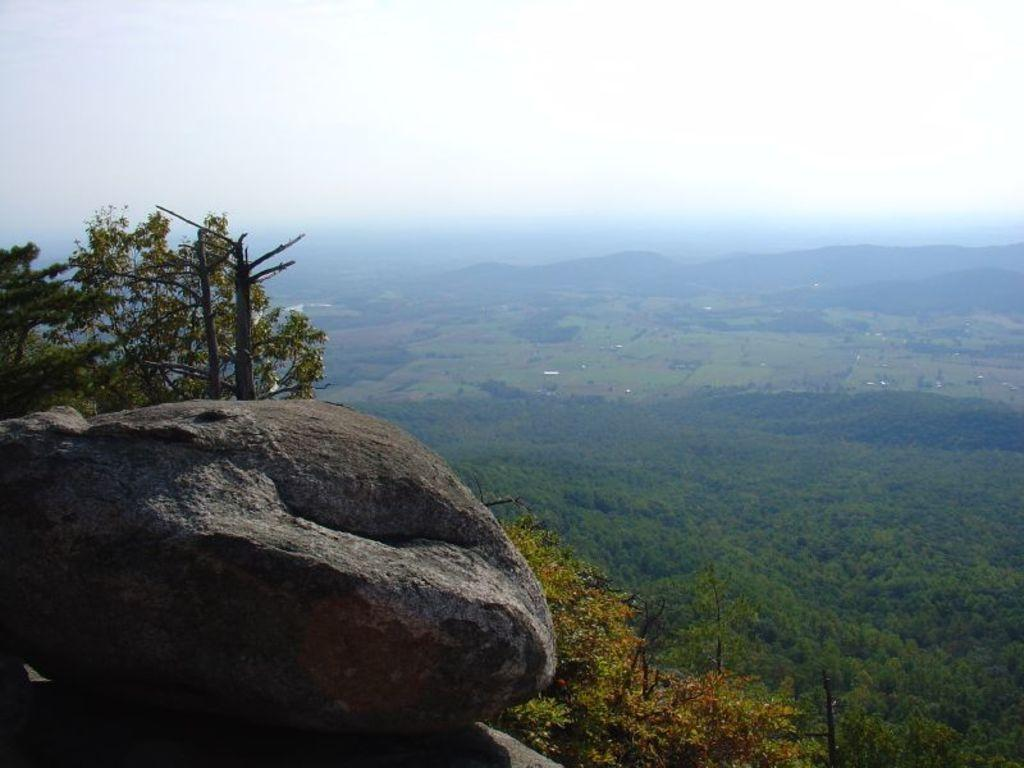What geographical feature is located on the left side of the image? There is a hill on the left side of the image. What type of vegetation is behind the hill? Trees are present behind the hill. How is the land in the background characterized? The land in the background is covered with plants and trees. What can be seen above the land in the image? The sky is visible above the land. What type of pancake is being balanced on the grade in the image? There is no pancake or grade present in the image; it features a hill, trees, and land covered with plants and trees. 